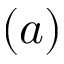Convert formula to latex. <formula><loc_0><loc_0><loc_500><loc_500>( a )</formula> 